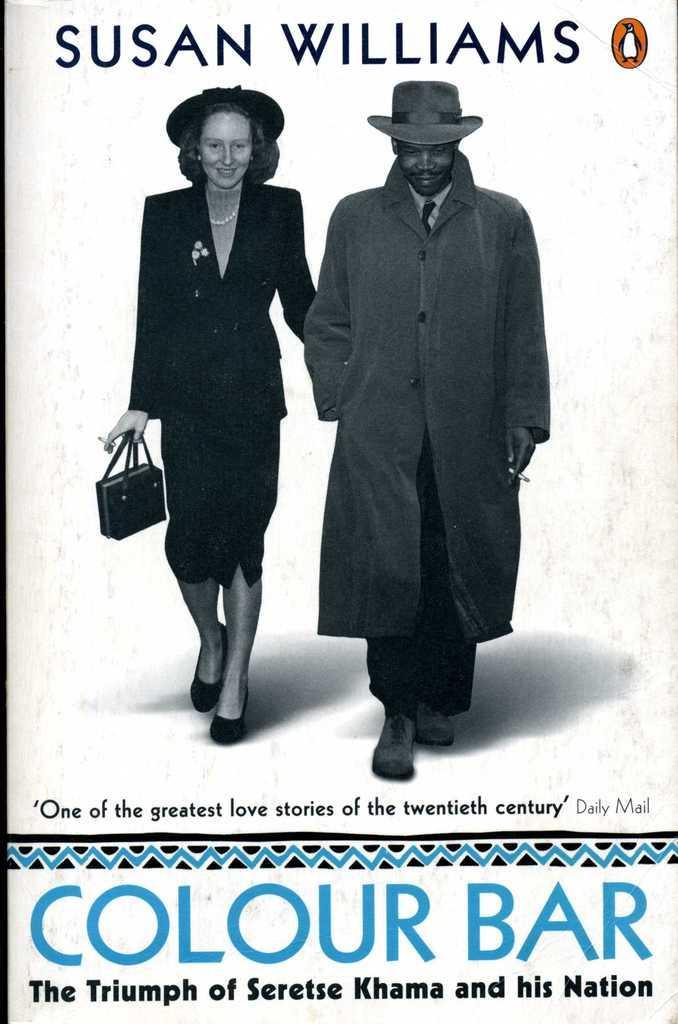Could you give a brief overview of what you see in this image? This image consists of a poster in which we can see a man and a woman. Both are wearing coats and hats. At the bottom, there is a text. 